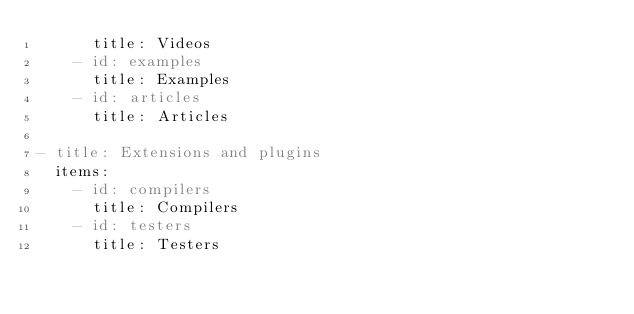Convert code to text. <code><loc_0><loc_0><loc_500><loc_500><_YAML_>      title: Videos
    - id: examples
      title: Examples
    - id: articles
      title: Articles

- title: Extensions and plugins
  items:
    - id: compilers
      title: Compilers
    - id: testers
      title: Testers
    </code> 